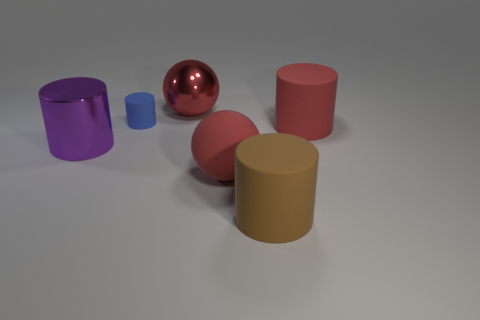Subtract all red cylinders. How many cylinders are left? 3 Subtract all blue cylinders. How many cylinders are left? 3 Add 2 tiny gray metallic things. How many objects exist? 8 Subtract 3 cylinders. How many cylinders are left? 1 Subtract 2 red spheres. How many objects are left? 4 Subtract all cylinders. How many objects are left? 2 Subtract all yellow cylinders. Subtract all yellow balls. How many cylinders are left? 4 Subtract all gray blocks. How many brown cylinders are left? 1 Subtract all green metallic cylinders. Subtract all small things. How many objects are left? 5 Add 5 tiny rubber objects. How many tiny rubber objects are left? 6 